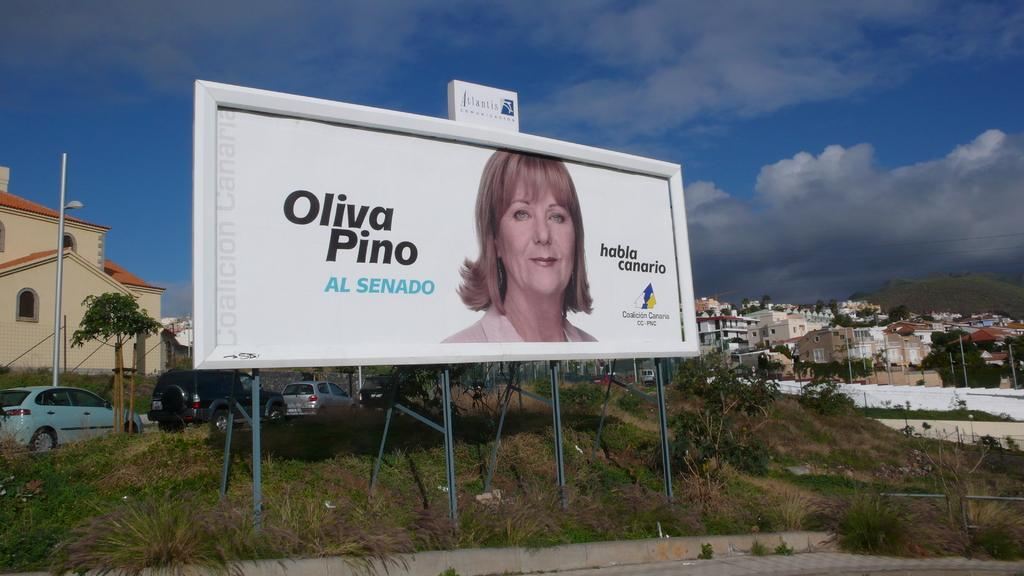<image>
Render a clear and concise summary of the photo. A large billboard with a woman's face and Oliva Pino on it. 